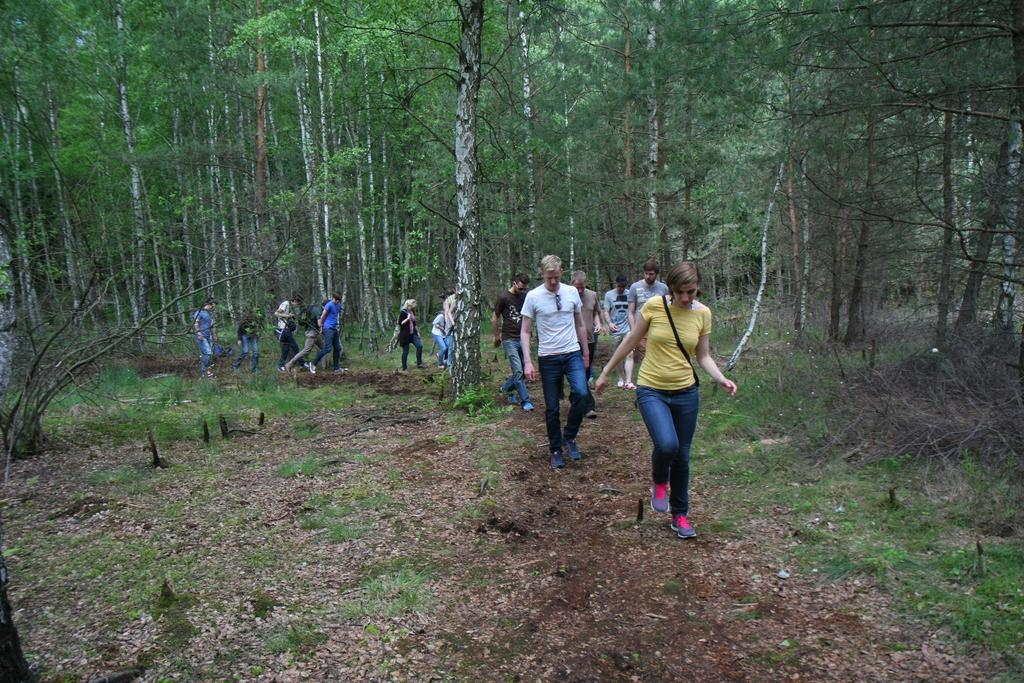What type of terrain is visible in the image? There is an open grass ground in the image. What are the people in the image doing? People are walking on the grass ground. Are any of the people carrying anything? Yes, some people are carrying bags. What can be seen in the background of the image? There are trees visible in the image. What type of advertisement can be seen on the grass ground in the image? There is no advertisement present on the grass ground in the image. Is there a volcano visible in the image? No, there is no volcano present in the image. 